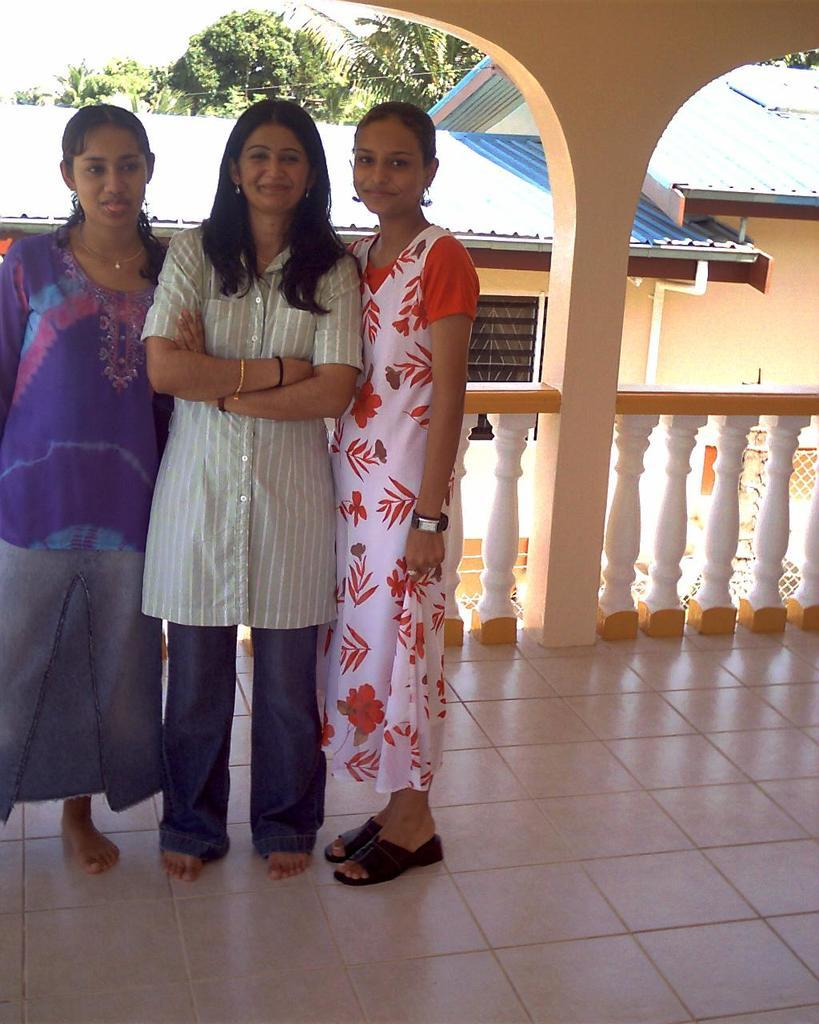How many women are in the image? There are three women in the image. What are the women wearing? The women are wearing dresses. Where are the women standing? The women are standing on the floor. What can be seen in the background of the image? There is a fence, a building, a group of trees, and the sky visible in the background of the image. What type of card is the bird smashing in the image? There is no card or bird present in the image. 